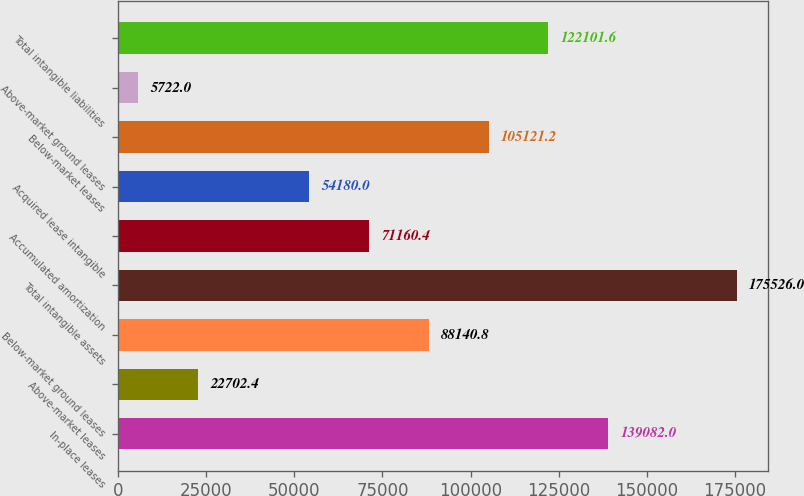Convert chart to OTSL. <chart><loc_0><loc_0><loc_500><loc_500><bar_chart><fcel>In-place leases<fcel>Above-market leases<fcel>Below-market ground leases<fcel>Total intangible assets<fcel>Accumulated amortization<fcel>Acquired lease intangible<fcel>Below-market leases<fcel>Above-market ground leases<fcel>Total intangible liabilities<nl><fcel>139082<fcel>22702.4<fcel>88140.8<fcel>175526<fcel>71160.4<fcel>54180<fcel>105121<fcel>5722<fcel>122102<nl></chart> 